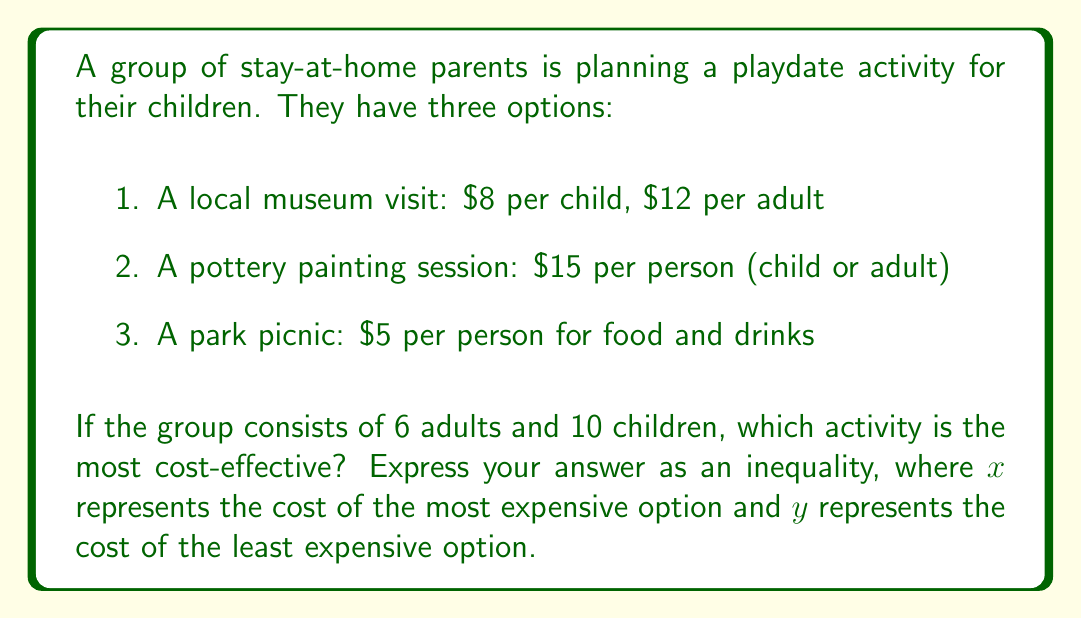Give your solution to this math problem. Let's calculate the cost for each option:

1. Museum visit:
   Cost = $(10 \times 8) + (6 \times 12) = 80 + 72 = 152$

2. Pottery painting:
   Cost = $15 \times (10 + 6) = 15 \times 16 = 240$

3. Park picnic:
   Cost = $5 \times (10 + 6) = 5 \times 16 = 80$

Ordering from least to most expensive:
Park picnic ($80) < Museum visit ($152) < Pottery painting ($240)

To express this as an inequality:
Let $y = 80$ (least expensive option)
Let $x = 240$ (most expensive option)

The inequality that represents this relationship is:

$$y < 152 < x$$

This inequality shows that the cost of the middle option (museum visit) is greater than the least expensive option (y) and less than the most expensive option (x).
Answer: $y < 152 < x$ 